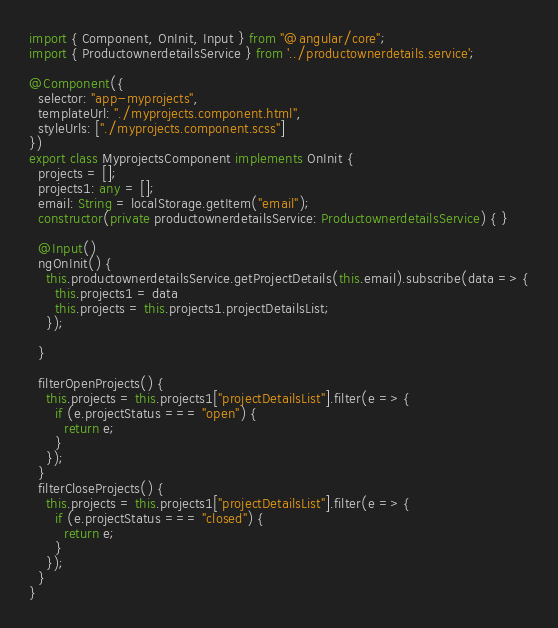Convert code to text. <code><loc_0><loc_0><loc_500><loc_500><_TypeScript_>import { Component, OnInit, Input } from "@angular/core";
import { ProductownerdetailsService } from '../productownerdetails.service';

@Component({
  selector: "app-myprojects",
  templateUrl: "./myprojects.component.html",
  styleUrls: ["./myprojects.component.scss"]
})
export class MyprojectsComponent implements OnInit {
  projects = [];
  projects1: any = [];
  email: String = localStorage.getItem("email");
  constructor(private productownerdetailsService: ProductownerdetailsService) { }

  @Input()
  ngOnInit() {
    this.productownerdetailsService.getProjectDetails(this.email).subscribe(data => {
      this.projects1 = data
      this.projects = this.projects1.projectDetailsList;
    });

  }

  filterOpenProjects() {
    this.projects = this.projects1["projectDetailsList"].filter(e => {
      if (e.projectStatus === "open") {
        return e;
      }
    });
  }
  filterCloseProjects() {
    this.projects = this.projects1["projectDetailsList"].filter(e => {
      if (e.projectStatus === "closed") {
        return e;
      }
    });
  }
}
</code> 